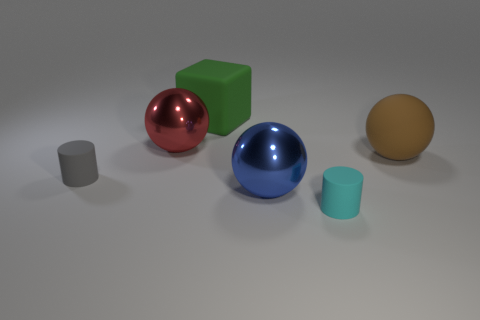Add 3 tiny purple cylinders. How many objects exist? 9 Subtract all cylinders. How many objects are left? 4 Add 1 large green blocks. How many large green blocks exist? 2 Subtract 0 purple cubes. How many objects are left? 6 Subtract all tiny blue rubber cylinders. Subtract all matte spheres. How many objects are left? 5 Add 6 metal things. How many metal things are left? 8 